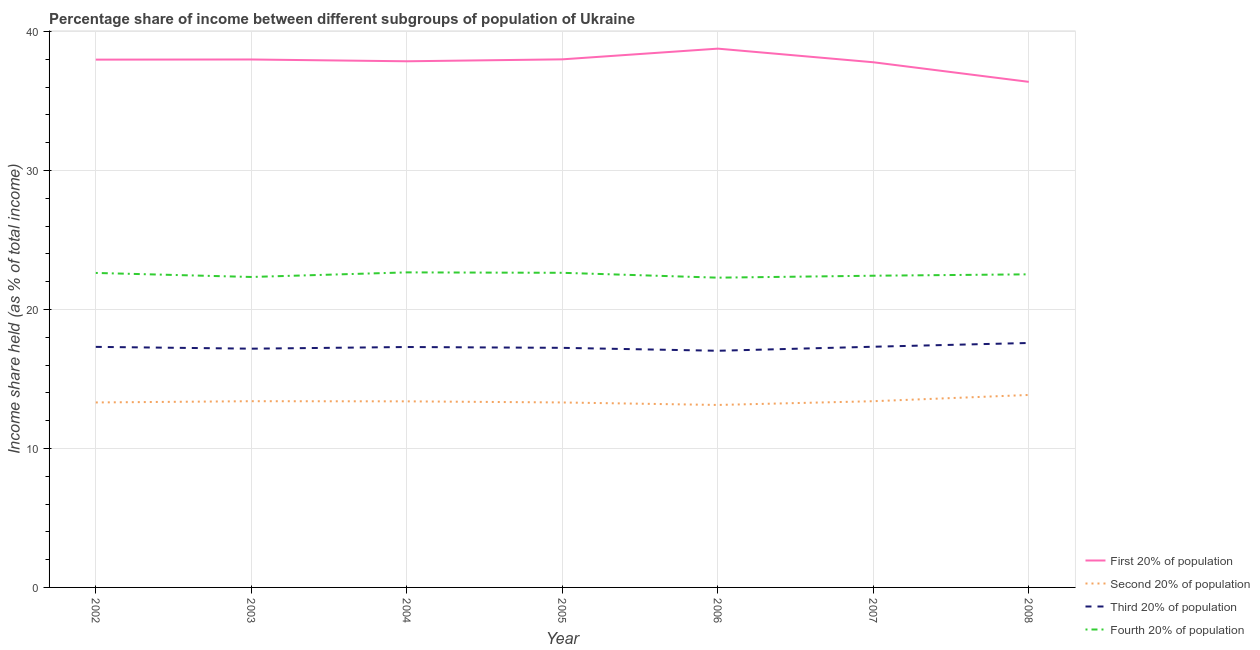How many different coloured lines are there?
Offer a terse response. 4. Is the number of lines equal to the number of legend labels?
Your answer should be compact. Yes. Across all years, what is the maximum share of the income held by first 20% of the population?
Offer a very short reply. 38.77. Across all years, what is the minimum share of the income held by first 20% of the population?
Keep it short and to the point. 36.38. In which year was the share of the income held by first 20% of the population maximum?
Provide a short and direct response. 2006. What is the total share of the income held by first 20% of the population in the graph?
Offer a terse response. 264.77. What is the difference between the share of the income held by first 20% of the population in 2005 and that in 2007?
Your response must be concise. 0.21. What is the difference between the share of the income held by third 20% of the population in 2007 and the share of the income held by fourth 20% of the population in 2008?
Offer a very short reply. -5.21. What is the average share of the income held by second 20% of the population per year?
Offer a terse response. 13.4. In the year 2007, what is the difference between the share of the income held by third 20% of the population and share of the income held by first 20% of the population?
Provide a short and direct response. -20.47. What is the ratio of the share of the income held by fourth 20% of the population in 2004 to that in 2008?
Make the answer very short. 1.01. Is the difference between the share of the income held by third 20% of the population in 2003 and 2004 greater than the difference between the share of the income held by fourth 20% of the population in 2003 and 2004?
Make the answer very short. Yes. What is the difference between the highest and the second highest share of the income held by third 20% of the population?
Offer a terse response. 0.27. What is the difference between the highest and the lowest share of the income held by first 20% of the population?
Your answer should be very brief. 2.39. Is the sum of the share of the income held by fourth 20% of the population in 2003 and 2005 greater than the maximum share of the income held by first 20% of the population across all years?
Keep it short and to the point. Yes. Is the share of the income held by first 20% of the population strictly less than the share of the income held by third 20% of the population over the years?
Provide a succinct answer. No. What is the difference between two consecutive major ticks on the Y-axis?
Provide a short and direct response. 10. Are the values on the major ticks of Y-axis written in scientific E-notation?
Offer a very short reply. No. Does the graph contain any zero values?
Provide a succinct answer. No. Does the graph contain grids?
Your response must be concise. Yes. How are the legend labels stacked?
Keep it short and to the point. Vertical. What is the title of the graph?
Give a very brief answer. Percentage share of income between different subgroups of population of Ukraine. What is the label or title of the X-axis?
Provide a short and direct response. Year. What is the label or title of the Y-axis?
Keep it short and to the point. Income share held (as % of total income). What is the Income share held (as % of total income) in First 20% of population in 2002?
Make the answer very short. 37.98. What is the Income share held (as % of total income) in Second 20% of population in 2002?
Provide a short and direct response. 13.31. What is the Income share held (as % of total income) in Third 20% of population in 2002?
Offer a terse response. 17.31. What is the Income share held (as % of total income) in Fourth 20% of population in 2002?
Provide a short and direct response. 22.63. What is the Income share held (as % of total income) of First 20% of population in 2003?
Give a very brief answer. 37.99. What is the Income share held (as % of total income) in Third 20% of population in 2003?
Keep it short and to the point. 17.18. What is the Income share held (as % of total income) in Fourth 20% of population in 2003?
Offer a terse response. 22.34. What is the Income share held (as % of total income) of First 20% of population in 2004?
Your answer should be very brief. 37.86. What is the Income share held (as % of total income) of Second 20% of population in 2004?
Give a very brief answer. 13.39. What is the Income share held (as % of total income) in Fourth 20% of population in 2004?
Keep it short and to the point. 22.67. What is the Income share held (as % of total income) of Second 20% of population in 2005?
Offer a very short reply. 13.31. What is the Income share held (as % of total income) in Third 20% of population in 2005?
Give a very brief answer. 17.24. What is the Income share held (as % of total income) of Fourth 20% of population in 2005?
Your answer should be very brief. 22.64. What is the Income share held (as % of total income) in First 20% of population in 2006?
Provide a succinct answer. 38.77. What is the Income share held (as % of total income) in Second 20% of population in 2006?
Ensure brevity in your answer.  13.13. What is the Income share held (as % of total income) in Third 20% of population in 2006?
Your answer should be very brief. 17.03. What is the Income share held (as % of total income) in Fourth 20% of population in 2006?
Give a very brief answer. 22.29. What is the Income share held (as % of total income) in First 20% of population in 2007?
Make the answer very short. 37.79. What is the Income share held (as % of total income) of Second 20% of population in 2007?
Offer a terse response. 13.4. What is the Income share held (as % of total income) in Third 20% of population in 2007?
Give a very brief answer. 17.32. What is the Income share held (as % of total income) in Fourth 20% of population in 2007?
Keep it short and to the point. 22.43. What is the Income share held (as % of total income) of First 20% of population in 2008?
Provide a short and direct response. 36.38. What is the Income share held (as % of total income) of Second 20% of population in 2008?
Your answer should be compact. 13.85. What is the Income share held (as % of total income) in Third 20% of population in 2008?
Give a very brief answer. 17.59. What is the Income share held (as % of total income) in Fourth 20% of population in 2008?
Ensure brevity in your answer.  22.53. Across all years, what is the maximum Income share held (as % of total income) of First 20% of population?
Keep it short and to the point. 38.77. Across all years, what is the maximum Income share held (as % of total income) in Second 20% of population?
Offer a terse response. 13.85. Across all years, what is the maximum Income share held (as % of total income) in Third 20% of population?
Your response must be concise. 17.59. Across all years, what is the maximum Income share held (as % of total income) in Fourth 20% of population?
Your answer should be compact. 22.67. Across all years, what is the minimum Income share held (as % of total income) of First 20% of population?
Keep it short and to the point. 36.38. Across all years, what is the minimum Income share held (as % of total income) in Second 20% of population?
Your answer should be compact. 13.13. Across all years, what is the minimum Income share held (as % of total income) in Third 20% of population?
Provide a short and direct response. 17.03. Across all years, what is the minimum Income share held (as % of total income) of Fourth 20% of population?
Keep it short and to the point. 22.29. What is the total Income share held (as % of total income) in First 20% of population in the graph?
Provide a succinct answer. 264.77. What is the total Income share held (as % of total income) in Second 20% of population in the graph?
Your answer should be very brief. 93.79. What is the total Income share held (as % of total income) in Third 20% of population in the graph?
Give a very brief answer. 120.97. What is the total Income share held (as % of total income) of Fourth 20% of population in the graph?
Your answer should be compact. 157.53. What is the difference between the Income share held (as % of total income) in First 20% of population in 2002 and that in 2003?
Provide a succinct answer. -0.01. What is the difference between the Income share held (as % of total income) of Second 20% of population in 2002 and that in 2003?
Offer a very short reply. -0.09. What is the difference between the Income share held (as % of total income) of Third 20% of population in 2002 and that in 2003?
Offer a very short reply. 0.13. What is the difference between the Income share held (as % of total income) in Fourth 20% of population in 2002 and that in 2003?
Offer a terse response. 0.29. What is the difference between the Income share held (as % of total income) of First 20% of population in 2002 and that in 2004?
Your answer should be very brief. 0.12. What is the difference between the Income share held (as % of total income) in Second 20% of population in 2002 and that in 2004?
Your answer should be very brief. -0.08. What is the difference between the Income share held (as % of total income) of Third 20% of population in 2002 and that in 2004?
Your answer should be very brief. 0.01. What is the difference between the Income share held (as % of total income) in Fourth 20% of population in 2002 and that in 2004?
Provide a short and direct response. -0.04. What is the difference between the Income share held (as % of total income) in First 20% of population in 2002 and that in 2005?
Offer a very short reply. -0.02. What is the difference between the Income share held (as % of total income) in Third 20% of population in 2002 and that in 2005?
Provide a succinct answer. 0.07. What is the difference between the Income share held (as % of total income) in Fourth 20% of population in 2002 and that in 2005?
Offer a very short reply. -0.01. What is the difference between the Income share held (as % of total income) in First 20% of population in 2002 and that in 2006?
Provide a succinct answer. -0.79. What is the difference between the Income share held (as % of total income) in Second 20% of population in 2002 and that in 2006?
Keep it short and to the point. 0.18. What is the difference between the Income share held (as % of total income) of Third 20% of population in 2002 and that in 2006?
Offer a very short reply. 0.28. What is the difference between the Income share held (as % of total income) in Fourth 20% of population in 2002 and that in 2006?
Your answer should be compact. 0.34. What is the difference between the Income share held (as % of total income) of First 20% of population in 2002 and that in 2007?
Keep it short and to the point. 0.19. What is the difference between the Income share held (as % of total income) of Second 20% of population in 2002 and that in 2007?
Provide a succinct answer. -0.09. What is the difference between the Income share held (as % of total income) of Third 20% of population in 2002 and that in 2007?
Make the answer very short. -0.01. What is the difference between the Income share held (as % of total income) of Fourth 20% of population in 2002 and that in 2007?
Offer a very short reply. 0.2. What is the difference between the Income share held (as % of total income) of First 20% of population in 2002 and that in 2008?
Give a very brief answer. 1.6. What is the difference between the Income share held (as % of total income) in Second 20% of population in 2002 and that in 2008?
Provide a succinct answer. -0.54. What is the difference between the Income share held (as % of total income) in Third 20% of population in 2002 and that in 2008?
Give a very brief answer. -0.28. What is the difference between the Income share held (as % of total income) in Fourth 20% of population in 2002 and that in 2008?
Make the answer very short. 0.1. What is the difference between the Income share held (as % of total income) of First 20% of population in 2003 and that in 2004?
Make the answer very short. 0.13. What is the difference between the Income share held (as % of total income) in Third 20% of population in 2003 and that in 2004?
Provide a succinct answer. -0.12. What is the difference between the Income share held (as % of total income) of Fourth 20% of population in 2003 and that in 2004?
Keep it short and to the point. -0.33. What is the difference between the Income share held (as % of total income) of First 20% of population in 2003 and that in 2005?
Your response must be concise. -0.01. What is the difference between the Income share held (as % of total income) of Second 20% of population in 2003 and that in 2005?
Make the answer very short. 0.09. What is the difference between the Income share held (as % of total income) in Third 20% of population in 2003 and that in 2005?
Offer a terse response. -0.06. What is the difference between the Income share held (as % of total income) in Fourth 20% of population in 2003 and that in 2005?
Your answer should be very brief. -0.3. What is the difference between the Income share held (as % of total income) of First 20% of population in 2003 and that in 2006?
Your response must be concise. -0.78. What is the difference between the Income share held (as % of total income) of Second 20% of population in 2003 and that in 2006?
Ensure brevity in your answer.  0.27. What is the difference between the Income share held (as % of total income) in Third 20% of population in 2003 and that in 2006?
Provide a succinct answer. 0.15. What is the difference between the Income share held (as % of total income) of Third 20% of population in 2003 and that in 2007?
Your response must be concise. -0.14. What is the difference between the Income share held (as % of total income) in Fourth 20% of population in 2003 and that in 2007?
Offer a terse response. -0.09. What is the difference between the Income share held (as % of total income) of First 20% of population in 2003 and that in 2008?
Make the answer very short. 1.61. What is the difference between the Income share held (as % of total income) of Second 20% of population in 2003 and that in 2008?
Provide a succinct answer. -0.45. What is the difference between the Income share held (as % of total income) in Third 20% of population in 2003 and that in 2008?
Provide a succinct answer. -0.41. What is the difference between the Income share held (as % of total income) in Fourth 20% of population in 2003 and that in 2008?
Your response must be concise. -0.19. What is the difference between the Income share held (as % of total income) of First 20% of population in 2004 and that in 2005?
Offer a very short reply. -0.14. What is the difference between the Income share held (as % of total income) of Fourth 20% of population in 2004 and that in 2005?
Offer a terse response. 0.03. What is the difference between the Income share held (as % of total income) in First 20% of population in 2004 and that in 2006?
Make the answer very short. -0.91. What is the difference between the Income share held (as % of total income) in Second 20% of population in 2004 and that in 2006?
Provide a succinct answer. 0.26. What is the difference between the Income share held (as % of total income) in Third 20% of population in 2004 and that in 2006?
Make the answer very short. 0.27. What is the difference between the Income share held (as % of total income) in Fourth 20% of population in 2004 and that in 2006?
Offer a very short reply. 0.38. What is the difference between the Income share held (as % of total income) of First 20% of population in 2004 and that in 2007?
Offer a very short reply. 0.07. What is the difference between the Income share held (as % of total income) in Second 20% of population in 2004 and that in 2007?
Your answer should be compact. -0.01. What is the difference between the Income share held (as % of total income) in Third 20% of population in 2004 and that in 2007?
Your response must be concise. -0.02. What is the difference between the Income share held (as % of total income) of Fourth 20% of population in 2004 and that in 2007?
Offer a terse response. 0.24. What is the difference between the Income share held (as % of total income) of First 20% of population in 2004 and that in 2008?
Offer a terse response. 1.48. What is the difference between the Income share held (as % of total income) in Second 20% of population in 2004 and that in 2008?
Keep it short and to the point. -0.46. What is the difference between the Income share held (as % of total income) in Third 20% of population in 2004 and that in 2008?
Offer a very short reply. -0.29. What is the difference between the Income share held (as % of total income) in Fourth 20% of population in 2004 and that in 2008?
Offer a terse response. 0.14. What is the difference between the Income share held (as % of total income) of First 20% of population in 2005 and that in 2006?
Your answer should be very brief. -0.77. What is the difference between the Income share held (as % of total income) in Second 20% of population in 2005 and that in 2006?
Your answer should be compact. 0.18. What is the difference between the Income share held (as % of total income) of Third 20% of population in 2005 and that in 2006?
Give a very brief answer. 0.21. What is the difference between the Income share held (as % of total income) in First 20% of population in 2005 and that in 2007?
Your answer should be compact. 0.21. What is the difference between the Income share held (as % of total income) of Second 20% of population in 2005 and that in 2007?
Your answer should be compact. -0.09. What is the difference between the Income share held (as % of total income) of Third 20% of population in 2005 and that in 2007?
Ensure brevity in your answer.  -0.08. What is the difference between the Income share held (as % of total income) in Fourth 20% of population in 2005 and that in 2007?
Keep it short and to the point. 0.21. What is the difference between the Income share held (as % of total income) of First 20% of population in 2005 and that in 2008?
Make the answer very short. 1.62. What is the difference between the Income share held (as % of total income) in Second 20% of population in 2005 and that in 2008?
Make the answer very short. -0.54. What is the difference between the Income share held (as % of total income) in Third 20% of population in 2005 and that in 2008?
Provide a short and direct response. -0.35. What is the difference between the Income share held (as % of total income) in Fourth 20% of population in 2005 and that in 2008?
Give a very brief answer. 0.11. What is the difference between the Income share held (as % of total income) of First 20% of population in 2006 and that in 2007?
Keep it short and to the point. 0.98. What is the difference between the Income share held (as % of total income) in Second 20% of population in 2006 and that in 2007?
Your answer should be very brief. -0.27. What is the difference between the Income share held (as % of total income) of Third 20% of population in 2006 and that in 2007?
Give a very brief answer. -0.29. What is the difference between the Income share held (as % of total income) of Fourth 20% of population in 2006 and that in 2007?
Make the answer very short. -0.14. What is the difference between the Income share held (as % of total income) of First 20% of population in 2006 and that in 2008?
Provide a succinct answer. 2.39. What is the difference between the Income share held (as % of total income) in Second 20% of population in 2006 and that in 2008?
Make the answer very short. -0.72. What is the difference between the Income share held (as % of total income) in Third 20% of population in 2006 and that in 2008?
Offer a terse response. -0.56. What is the difference between the Income share held (as % of total income) in Fourth 20% of population in 2006 and that in 2008?
Your response must be concise. -0.24. What is the difference between the Income share held (as % of total income) of First 20% of population in 2007 and that in 2008?
Ensure brevity in your answer.  1.41. What is the difference between the Income share held (as % of total income) in Second 20% of population in 2007 and that in 2008?
Offer a terse response. -0.45. What is the difference between the Income share held (as % of total income) in Third 20% of population in 2007 and that in 2008?
Offer a terse response. -0.27. What is the difference between the Income share held (as % of total income) in Fourth 20% of population in 2007 and that in 2008?
Offer a terse response. -0.1. What is the difference between the Income share held (as % of total income) of First 20% of population in 2002 and the Income share held (as % of total income) of Second 20% of population in 2003?
Ensure brevity in your answer.  24.58. What is the difference between the Income share held (as % of total income) in First 20% of population in 2002 and the Income share held (as % of total income) in Third 20% of population in 2003?
Make the answer very short. 20.8. What is the difference between the Income share held (as % of total income) of First 20% of population in 2002 and the Income share held (as % of total income) of Fourth 20% of population in 2003?
Your answer should be very brief. 15.64. What is the difference between the Income share held (as % of total income) of Second 20% of population in 2002 and the Income share held (as % of total income) of Third 20% of population in 2003?
Your response must be concise. -3.87. What is the difference between the Income share held (as % of total income) in Second 20% of population in 2002 and the Income share held (as % of total income) in Fourth 20% of population in 2003?
Offer a terse response. -9.03. What is the difference between the Income share held (as % of total income) of Third 20% of population in 2002 and the Income share held (as % of total income) of Fourth 20% of population in 2003?
Give a very brief answer. -5.03. What is the difference between the Income share held (as % of total income) of First 20% of population in 2002 and the Income share held (as % of total income) of Second 20% of population in 2004?
Provide a short and direct response. 24.59. What is the difference between the Income share held (as % of total income) of First 20% of population in 2002 and the Income share held (as % of total income) of Third 20% of population in 2004?
Make the answer very short. 20.68. What is the difference between the Income share held (as % of total income) in First 20% of population in 2002 and the Income share held (as % of total income) in Fourth 20% of population in 2004?
Provide a short and direct response. 15.31. What is the difference between the Income share held (as % of total income) of Second 20% of population in 2002 and the Income share held (as % of total income) of Third 20% of population in 2004?
Provide a succinct answer. -3.99. What is the difference between the Income share held (as % of total income) in Second 20% of population in 2002 and the Income share held (as % of total income) in Fourth 20% of population in 2004?
Your answer should be compact. -9.36. What is the difference between the Income share held (as % of total income) of Third 20% of population in 2002 and the Income share held (as % of total income) of Fourth 20% of population in 2004?
Offer a terse response. -5.36. What is the difference between the Income share held (as % of total income) in First 20% of population in 2002 and the Income share held (as % of total income) in Second 20% of population in 2005?
Offer a terse response. 24.67. What is the difference between the Income share held (as % of total income) in First 20% of population in 2002 and the Income share held (as % of total income) in Third 20% of population in 2005?
Your response must be concise. 20.74. What is the difference between the Income share held (as % of total income) of First 20% of population in 2002 and the Income share held (as % of total income) of Fourth 20% of population in 2005?
Provide a succinct answer. 15.34. What is the difference between the Income share held (as % of total income) in Second 20% of population in 2002 and the Income share held (as % of total income) in Third 20% of population in 2005?
Your answer should be very brief. -3.93. What is the difference between the Income share held (as % of total income) in Second 20% of population in 2002 and the Income share held (as % of total income) in Fourth 20% of population in 2005?
Provide a short and direct response. -9.33. What is the difference between the Income share held (as % of total income) of Third 20% of population in 2002 and the Income share held (as % of total income) of Fourth 20% of population in 2005?
Ensure brevity in your answer.  -5.33. What is the difference between the Income share held (as % of total income) of First 20% of population in 2002 and the Income share held (as % of total income) of Second 20% of population in 2006?
Make the answer very short. 24.85. What is the difference between the Income share held (as % of total income) of First 20% of population in 2002 and the Income share held (as % of total income) of Third 20% of population in 2006?
Your answer should be very brief. 20.95. What is the difference between the Income share held (as % of total income) of First 20% of population in 2002 and the Income share held (as % of total income) of Fourth 20% of population in 2006?
Your answer should be very brief. 15.69. What is the difference between the Income share held (as % of total income) of Second 20% of population in 2002 and the Income share held (as % of total income) of Third 20% of population in 2006?
Give a very brief answer. -3.72. What is the difference between the Income share held (as % of total income) of Second 20% of population in 2002 and the Income share held (as % of total income) of Fourth 20% of population in 2006?
Your answer should be compact. -8.98. What is the difference between the Income share held (as % of total income) of Third 20% of population in 2002 and the Income share held (as % of total income) of Fourth 20% of population in 2006?
Ensure brevity in your answer.  -4.98. What is the difference between the Income share held (as % of total income) in First 20% of population in 2002 and the Income share held (as % of total income) in Second 20% of population in 2007?
Provide a short and direct response. 24.58. What is the difference between the Income share held (as % of total income) in First 20% of population in 2002 and the Income share held (as % of total income) in Third 20% of population in 2007?
Provide a short and direct response. 20.66. What is the difference between the Income share held (as % of total income) in First 20% of population in 2002 and the Income share held (as % of total income) in Fourth 20% of population in 2007?
Your answer should be very brief. 15.55. What is the difference between the Income share held (as % of total income) in Second 20% of population in 2002 and the Income share held (as % of total income) in Third 20% of population in 2007?
Provide a succinct answer. -4.01. What is the difference between the Income share held (as % of total income) in Second 20% of population in 2002 and the Income share held (as % of total income) in Fourth 20% of population in 2007?
Provide a succinct answer. -9.12. What is the difference between the Income share held (as % of total income) of Third 20% of population in 2002 and the Income share held (as % of total income) of Fourth 20% of population in 2007?
Provide a succinct answer. -5.12. What is the difference between the Income share held (as % of total income) of First 20% of population in 2002 and the Income share held (as % of total income) of Second 20% of population in 2008?
Offer a very short reply. 24.13. What is the difference between the Income share held (as % of total income) of First 20% of population in 2002 and the Income share held (as % of total income) of Third 20% of population in 2008?
Your answer should be compact. 20.39. What is the difference between the Income share held (as % of total income) of First 20% of population in 2002 and the Income share held (as % of total income) of Fourth 20% of population in 2008?
Your answer should be very brief. 15.45. What is the difference between the Income share held (as % of total income) in Second 20% of population in 2002 and the Income share held (as % of total income) in Third 20% of population in 2008?
Provide a short and direct response. -4.28. What is the difference between the Income share held (as % of total income) of Second 20% of population in 2002 and the Income share held (as % of total income) of Fourth 20% of population in 2008?
Provide a short and direct response. -9.22. What is the difference between the Income share held (as % of total income) of Third 20% of population in 2002 and the Income share held (as % of total income) of Fourth 20% of population in 2008?
Keep it short and to the point. -5.22. What is the difference between the Income share held (as % of total income) of First 20% of population in 2003 and the Income share held (as % of total income) of Second 20% of population in 2004?
Offer a very short reply. 24.6. What is the difference between the Income share held (as % of total income) in First 20% of population in 2003 and the Income share held (as % of total income) in Third 20% of population in 2004?
Offer a very short reply. 20.69. What is the difference between the Income share held (as % of total income) of First 20% of population in 2003 and the Income share held (as % of total income) of Fourth 20% of population in 2004?
Provide a succinct answer. 15.32. What is the difference between the Income share held (as % of total income) in Second 20% of population in 2003 and the Income share held (as % of total income) in Third 20% of population in 2004?
Your response must be concise. -3.9. What is the difference between the Income share held (as % of total income) of Second 20% of population in 2003 and the Income share held (as % of total income) of Fourth 20% of population in 2004?
Give a very brief answer. -9.27. What is the difference between the Income share held (as % of total income) of Third 20% of population in 2003 and the Income share held (as % of total income) of Fourth 20% of population in 2004?
Make the answer very short. -5.49. What is the difference between the Income share held (as % of total income) in First 20% of population in 2003 and the Income share held (as % of total income) in Second 20% of population in 2005?
Provide a succinct answer. 24.68. What is the difference between the Income share held (as % of total income) in First 20% of population in 2003 and the Income share held (as % of total income) in Third 20% of population in 2005?
Keep it short and to the point. 20.75. What is the difference between the Income share held (as % of total income) in First 20% of population in 2003 and the Income share held (as % of total income) in Fourth 20% of population in 2005?
Provide a succinct answer. 15.35. What is the difference between the Income share held (as % of total income) in Second 20% of population in 2003 and the Income share held (as % of total income) in Third 20% of population in 2005?
Your answer should be compact. -3.84. What is the difference between the Income share held (as % of total income) of Second 20% of population in 2003 and the Income share held (as % of total income) of Fourth 20% of population in 2005?
Your response must be concise. -9.24. What is the difference between the Income share held (as % of total income) of Third 20% of population in 2003 and the Income share held (as % of total income) of Fourth 20% of population in 2005?
Offer a terse response. -5.46. What is the difference between the Income share held (as % of total income) in First 20% of population in 2003 and the Income share held (as % of total income) in Second 20% of population in 2006?
Offer a terse response. 24.86. What is the difference between the Income share held (as % of total income) in First 20% of population in 2003 and the Income share held (as % of total income) in Third 20% of population in 2006?
Make the answer very short. 20.96. What is the difference between the Income share held (as % of total income) of First 20% of population in 2003 and the Income share held (as % of total income) of Fourth 20% of population in 2006?
Your answer should be compact. 15.7. What is the difference between the Income share held (as % of total income) in Second 20% of population in 2003 and the Income share held (as % of total income) in Third 20% of population in 2006?
Offer a terse response. -3.63. What is the difference between the Income share held (as % of total income) in Second 20% of population in 2003 and the Income share held (as % of total income) in Fourth 20% of population in 2006?
Provide a succinct answer. -8.89. What is the difference between the Income share held (as % of total income) of Third 20% of population in 2003 and the Income share held (as % of total income) of Fourth 20% of population in 2006?
Your answer should be compact. -5.11. What is the difference between the Income share held (as % of total income) of First 20% of population in 2003 and the Income share held (as % of total income) of Second 20% of population in 2007?
Provide a succinct answer. 24.59. What is the difference between the Income share held (as % of total income) of First 20% of population in 2003 and the Income share held (as % of total income) of Third 20% of population in 2007?
Your response must be concise. 20.67. What is the difference between the Income share held (as % of total income) of First 20% of population in 2003 and the Income share held (as % of total income) of Fourth 20% of population in 2007?
Provide a succinct answer. 15.56. What is the difference between the Income share held (as % of total income) of Second 20% of population in 2003 and the Income share held (as % of total income) of Third 20% of population in 2007?
Keep it short and to the point. -3.92. What is the difference between the Income share held (as % of total income) of Second 20% of population in 2003 and the Income share held (as % of total income) of Fourth 20% of population in 2007?
Make the answer very short. -9.03. What is the difference between the Income share held (as % of total income) of Third 20% of population in 2003 and the Income share held (as % of total income) of Fourth 20% of population in 2007?
Your answer should be very brief. -5.25. What is the difference between the Income share held (as % of total income) of First 20% of population in 2003 and the Income share held (as % of total income) of Second 20% of population in 2008?
Your answer should be very brief. 24.14. What is the difference between the Income share held (as % of total income) of First 20% of population in 2003 and the Income share held (as % of total income) of Third 20% of population in 2008?
Your response must be concise. 20.4. What is the difference between the Income share held (as % of total income) in First 20% of population in 2003 and the Income share held (as % of total income) in Fourth 20% of population in 2008?
Make the answer very short. 15.46. What is the difference between the Income share held (as % of total income) of Second 20% of population in 2003 and the Income share held (as % of total income) of Third 20% of population in 2008?
Provide a short and direct response. -4.19. What is the difference between the Income share held (as % of total income) in Second 20% of population in 2003 and the Income share held (as % of total income) in Fourth 20% of population in 2008?
Provide a short and direct response. -9.13. What is the difference between the Income share held (as % of total income) in Third 20% of population in 2003 and the Income share held (as % of total income) in Fourth 20% of population in 2008?
Provide a short and direct response. -5.35. What is the difference between the Income share held (as % of total income) of First 20% of population in 2004 and the Income share held (as % of total income) of Second 20% of population in 2005?
Make the answer very short. 24.55. What is the difference between the Income share held (as % of total income) in First 20% of population in 2004 and the Income share held (as % of total income) in Third 20% of population in 2005?
Your response must be concise. 20.62. What is the difference between the Income share held (as % of total income) in First 20% of population in 2004 and the Income share held (as % of total income) in Fourth 20% of population in 2005?
Provide a short and direct response. 15.22. What is the difference between the Income share held (as % of total income) in Second 20% of population in 2004 and the Income share held (as % of total income) in Third 20% of population in 2005?
Ensure brevity in your answer.  -3.85. What is the difference between the Income share held (as % of total income) in Second 20% of population in 2004 and the Income share held (as % of total income) in Fourth 20% of population in 2005?
Provide a short and direct response. -9.25. What is the difference between the Income share held (as % of total income) in Third 20% of population in 2004 and the Income share held (as % of total income) in Fourth 20% of population in 2005?
Offer a terse response. -5.34. What is the difference between the Income share held (as % of total income) of First 20% of population in 2004 and the Income share held (as % of total income) of Second 20% of population in 2006?
Make the answer very short. 24.73. What is the difference between the Income share held (as % of total income) of First 20% of population in 2004 and the Income share held (as % of total income) of Third 20% of population in 2006?
Provide a short and direct response. 20.83. What is the difference between the Income share held (as % of total income) in First 20% of population in 2004 and the Income share held (as % of total income) in Fourth 20% of population in 2006?
Your answer should be compact. 15.57. What is the difference between the Income share held (as % of total income) of Second 20% of population in 2004 and the Income share held (as % of total income) of Third 20% of population in 2006?
Make the answer very short. -3.64. What is the difference between the Income share held (as % of total income) in Third 20% of population in 2004 and the Income share held (as % of total income) in Fourth 20% of population in 2006?
Make the answer very short. -4.99. What is the difference between the Income share held (as % of total income) in First 20% of population in 2004 and the Income share held (as % of total income) in Second 20% of population in 2007?
Give a very brief answer. 24.46. What is the difference between the Income share held (as % of total income) in First 20% of population in 2004 and the Income share held (as % of total income) in Third 20% of population in 2007?
Your response must be concise. 20.54. What is the difference between the Income share held (as % of total income) of First 20% of population in 2004 and the Income share held (as % of total income) of Fourth 20% of population in 2007?
Ensure brevity in your answer.  15.43. What is the difference between the Income share held (as % of total income) in Second 20% of population in 2004 and the Income share held (as % of total income) in Third 20% of population in 2007?
Offer a very short reply. -3.93. What is the difference between the Income share held (as % of total income) of Second 20% of population in 2004 and the Income share held (as % of total income) of Fourth 20% of population in 2007?
Your answer should be very brief. -9.04. What is the difference between the Income share held (as % of total income) of Third 20% of population in 2004 and the Income share held (as % of total income) of Fourth 20% of population in 2007?
Your answer should be very brief. -5.13. What is the difference between the Income share held (as % of total income) in First 20% of population in 2004 and the Income share held (as % of total income) in Second 20% of population in 2008?
Your response must be concise. 24.01. What is the difference between the Income share held (as % of total income) of First 20% of population in 2004 and the Income share held (as % of total income) of Third 20% of population in 2008?
Your answer should be very brief. 20.27. What is the difference between the Income share held (as % of total income) in First 20% of population in 2004 and the Income share held (as % of total income) in Fourth 20% of population in 2008?
Offer a very short reply. 15.33. What is the difference between the Income share held (as % of total income) of Second 20% of population in 2004 and the Income share held (as % of total income) of Third 20% of population in 2008?
Your answer should be very brief. -4.2. What is the difference between the Income share held (as % of total income) of Second 20% of population in 2004 and the Income share held (as % of total income) of Fourth 20% of population in 2008?
Ensure brevity in your answer.  -9.14. What is the difference between the Income share held (as % of total income) of Third 20% of population in 2004 and the Income share held (as % of total income) of Fourth 20% of population in 2008?
Your response must be concise. -5.23. What is the difference between the Income share held (as % of total income) in First 20% of population in 2005 and the Income share held (as % of total income) in Second 20% of population in 2006?
Keep it short and to the point. 24.87. What is the difference between the Income share held (as % of total income) of First 20% of population in 2005 and the Income share held (as % of total income) of Third 20% of population in 2006?
Offer a very short reply. 20.97. What is the difference between the Income share held (as % of total income) of First 20% of population in 2005 and the Income share held (as % of total income) of Fourth 20% of population in 2006?
Give a very brief answer. 15.71. What is the difference between the Income share held (as % of total income) of Second 20% of population in 2005 and the Income share held (as % of total income) of Third 20% of population in 2006?
Your answer should be very brief. -3.72. What is the difference between the Income share held (as % of total income) of Second 20% of population in 2005 and the Income share held (as % of total income) of Fourth 20% of population in 2006?
Your response must be concise. -8.98. What is the difference between the Income share held (as % of total income) of Third 20% of population in 2005 and the Income share held (as % of total income) of Fourth 20% of population in 2006?
Your answer should be compact. -5.05. What is the difference between the Income share held (as % of total income) of First 20% of population in 2005 and the Income share held (as % of total income) of Second 20% of population in 2007?
Provide a short and direct response. 24.6. What is the difference between the Income share held (as % of total income) in First 20% of population in 2005 and the Income share held (as % of total income) in Third 20% of population in 2007?
Ensure brevity in your answer.  20.68. What is the difference between the Income share held (as % of total income) of First 20% of population in 2005 and the Income share held (as % of total income) of Fourth 20% of population in 2007?
Give a very brief answer. 15.57. What is the difference between the Income share held (as % of total income) of Second 20% of population in 2005 and the Income share held (as % of total income) of Third 20% of population in 2007?
Your response must be concise. -4.01. What is the difference between the Income share held (as % of total income) in Second 20% of population in 2005 and the Income share held (as % of total income) in Fourth 20% of population in 2007?
Ensure brevity in your answer.  -9.12. What is the difference between the Income share held (as % of total income) in Third 20% of population in 2005 and the Income share held (as % of total income) in Fourth 20% of population in 2007?
Offer a very short reply. -5.19. What is the difference between the Income share held (as % of total income) of First 20% of population in 2005 and the Income share held (as % of total income) of Second 20% of population in 2008?
Give a very brief answer. 24.15. What is the difference between the Income share held (as % of total income) of First 20% of population in 2005 and the Income share held (as % of total income) of Third 20% of population in 2008?
Keep it short and to the point. 20.41. What is the difference between the Income share held (as % of total income) in First 20% of population in 2005 and the Income share held (as % of total income) in Fourth 20% of population in 2008?
Your response must be concise. 15.47. What is the difference between the Income share held (as % of total income) in Second 20% of population in 2005 and the Income share held (as % of total income) in Third 20% of population in 2008?
Ensure brevity in your answer.  -4.28. What is the difference between the Income share held (as % of total income) of Second 20% of population in 2005 and the Income share held (as % of total income) of Fourth 20% of population in 2008?
Your response must be concise. -9.22. What is the difference between the Income share held (as % of total income) in Third 20% of population in 2005 and the Income share held (as % of total income) in Fourth 20% of population in 2008?
Offer a very short reply. -5.29. What is the difference between the Income share held (as % of total income) of First 20% of population in 2006 and the Income share held (as % of total income) of Second 20% of population in 2007?
Your answer should be very brief. 25.37. What is the difference between the Income share held (as % of total income) of First 20% of population in 2006 and the Income share held (as % of total income) of Third 20% of population in 2007?
Offer a very short reply. 21.45. What is the difference between the Income share held (as % of total income) of First 20% of population in 2006 and the Income share held (as % of total income) of Fourth 20% of population in 2007?
Offer a terse response. 16.34. What is the difference between the Income share held (as % of total income) in Second 20% of population in 2006 and the Income share held (as % of total income) in Third 20% of population in 2007?
Keep it short and to the point. -4.19. What is the difference between the Income share held (as % of total income) of Third 20% of population in 2006 and the Income share held (as % of total income) of Fourth 20% of population in 2007?
Your answer should be compact. -5.4. What is the difference between the Income share held (as % of total income) in First 20% of population in 2006 and the Income share held (as % of total income) in Second 20% of population in 2008?
Your answer should be very brief. 24.92. What is the difference between the Income share held (as % of total income) in First 20% of population in 2006 and the Income share held (as % of total income) in Third 20% of population in 2008?
Provide a short and direct response. 21.18. What is the difference between the Income share held (as % of total income) in First 20% of population in 2006 and the Income share held (as % of total income) in Fourth 20% of population in 2008?
Make the answer very short. 16.24. What is the difference between the Income share held (as % of total income) of Second 20% of population in 2006 and the Income share held (as % of total income) of Third 20% of population in 2008?
Give a very brief answer. -4.46. What is the difference between the Income share held (as % of total income) of Second 20% of population in 2006 and the Income share held (as % of total income) of Fourth 20% of population in 2008?
Offer a terse response. -9.4. What is the difference between the Income share held (as % of total income) in First 20% of population in 2007 and the Income share held (as % of total income) in Second 20% of population in 2008?
Offer a terse response. 23.94. What is the difference between the Income share held (as % of total income) in First 20% of population in 2007 and the Income share held (as % of total income) in Third 20% of population in 2008?
Ensure brevity in your answer.  20.2. What is the difference between the Income share held (as % of total income) in First 20% of population in 2007 and the Income share held (as % of total income) in Fourth 20% of population in 2008?
Give a very brief answer. 15.26. What is the difference between the Income share held (as % of total income) of Second 20% of population in 2007 and the Income share held (as % of total income) of Third 20% of population in 2008?
Provide a short and direct response. -4.19. What is the difference between the Income share held (as % of total income) in Second 20% of population in 2007 and the Income share held (as % of total income) in Fourth 20% of population in 2008?
Offer a very short reply. -9.13. What is the difference between the Income share held (as % of total income) in Third 20% of population in 2007 and the Income share held (as % of total income) in Fourth 20% of population in 2008?
Keep it short and to the point. -5.21. What is the average Income share held (as % of total income) in First 20% of population per year?
Provide a succinct answer. 37.82. What is the average Income share held (as % of total income) of Second 20% of population per year?
Provide a succinct answer. 13.4. What is the average Income share held (as % of total income) of Third 20% of population per year?
Give a very brief answer. 17.28. What is the average Income share held (as % of total income) of Fourth 20% of population per year?
Give a very brief answer. 22.5. In the year 2002, what is the difference between the Income share held (as % of total income) in First 20% of population and Income share held (as % of total income) in Second 20% of population?
Provide a succinct answer. 24.67. In the year 2002, what is the difference between the Income share held (as % of total income) of First 20% of population and Income share held (as % of total income) of Third 20% of population?
Your answer should be compact. 20.67. In the year 2002, what is the difference between the Income share held (as % of total income) of First 20% of population and Income share held (as % of total income) of Fourth 20% of population?
Keep it short and to the point. 15.35. In the year 2002, what is the difference between the Income share held (as % of total income) of Second 20% of population and Income share held (as % of total income) of Third 20% of population?
Provide a succinct answer. -4. In the year 2002, what is the difference between the Income share held (as % of total income) in Second 20% of population and Income share held (as % of total income) in Fourth 20% of population?
Offer a very short reply. -9.32. In the year 2002, what is the difference between the Income share held (as % of total income) in Third 20% of population and Income share held (as % of total income) in Fourth 20% of population?
Offer a terse response. -5.32. In the year 2003, what is the difference between the Income share held (as % of total income) in First 20% of population and Income share held (as % of total income) in Second 20% of population?
Provide a short and direct response. 24.59. In the year 2003, what is the difference between the Income share held (as % of total income) of First 20% of population and Income share held (as % of total income) of Third 20% of population?
Provide a short and direct response. 20.81. In the year 2003, what is the difference between the Income share held (as % of total income) in First 20% of population and Income share held (as % of total income) in Fourth 20% of population?
Offer a very short reply. 15.65. In the year 2003, what is the difference between the Income share held (as % of total income) in Second 20% of population and Income share held (as % of total income) in Third 20% of population?
Provide a succinct answer. -3.78. In the year 2003, what is the difference between the Income share held (as % of total income) of Second 20% of population and Income share held (as % of total income) of Fourth 20% of population?
Your answer should be very brief. -8.94. In the year 2003, what is the difference between the Income share held (as % of total income) in Third 20% of population and Income share held (as % of total income) in Fourth 20% of population?
Your answer should be very brief. -5.16. In the year 2004, what is the difference between the Income share held (as % of total income) in First 20% of population and Income share held (as % of total income) in Second 20% of population?
Make the answer very short. 24.47. In the year 2004, what is the difference between the Income share held (as % of total income) of First 20% of population and Income share held (as % of total income) of Third 20% of population?
Offer a terse response. 20.56. In the year 2004, what is the difference between the Income share held (as % of total income) of First 20% of population and Income share held (as % of total income) of Fourth 20% of population?
Your answer should be very brief. 15.19. In the year 2004, what is the difference between the Income share held (as % of total income) in Second 20% of population and Income share held (as % of total income) in Third 20% of population?
Offer a terse response. -3.91. In the year 2004, what is the difference between the Income share held (as % of total income) in Second 20% of population and Income share held (as % of total income) in Fourth 20% of population?
Make the answer very short. -9.28. In the year 2004, what is the difference between the Income share held (as % of total income) in Third 20% of population and Income share held (as % of total income) in Fourth 20% of population?
Offer a very short reply. -5.37. In the year 2005, what is the difference between the Income share held (as % of total income) of First 20% of population and Income share held (as % of total income) of Second 20% of population?
Keep it short and to the point. 24.69. In the year 2005, what is the difference between the Income share held (as % of total income) of First 20% of population and Income share held (as % of total income) of Third 20% of population?
Keep it short and to the point. 20.76. In the year 2005, what is the difference between the Income share held (as % of total income) in First 20% of population and Income share held (as % of total income) in Fourth 20% of population?
Offer a very short reply. 15.36. In the year 2005, what is the difference between the Income share held (as % of total income) in Second 20% of population and Income share held (as % of total income) in Third 20% of population?
Give a very brief answer. -3.93. In the year 2005, what is the difference between the Income share held (as % of total income) of Second 20% of population and Income share held (as % of total income) of Fourth 20% of population?
Give a very brief answer. -9.33. In the year 2006, what is the difference between the Income share held (as % of total income) in First 20% of population and Income share held (as % of total income) in Second 20% of population?
Offer a terse response. 25.64. In the year 2006, what is the difference between the Income share held (as % of total income) in First 20% of population and Income share held (as % of total income) in Third 20% of population?
Your response must be concise. 21.74. In the year 2006, what is the difference between the Income share held (as % of total income) in First 20% of population and Income share held (as % of total income) in Fourth 20% of population?
Provide a succinct answer. 16.48. In the year 2006, what is the difference between the Income share held (as % of total income) in Second 20% of population and Income share held (as % of total income) in Fourth 20% of population?
Keep it short and to the point. -9.16. In the year 2006, what is the difference between the Income share held (as % of total income) in Third 20% of population and Income share held (as % of total income) in Fourth 20% of population?
Offer a terse response. -5.26. In the year 2007, what is the difference between the Income share held (as % of total income) of First 20% of population and Income share held (as % of total income) of Second 20% of population?
Provide a succinct answer. 24.39. In the year 2007, what is the difference between the Income share held (as % of total income) in First 20% of population and Income share held (as % of total income) in Third 20% of population?
Give a very brief answer. 20.47. In the year 2007, what is the difference between the Income share held (as % of total income) of First 20% of population and Income share held (as % of total income) of Fourth 20% of population?
Provide a short and direct response. 15.36. In the year 2007, what is the difference between the Income share held (as % of total income) of Second 20% of population and Income share held (as % of total income) of Third 20% of population?
Provide a short and direct response. -3.92. In the year 2007, what is the difference between the Income share held (as % of total income) in Second 20% of population and Income share held (as % of total income) in Fourth 20% of population?
Your response must be concise. -9.03. In the year 2007, what is the difference between the Income share held (as % of total income) in Third 20% of population and Income share held (as % of total income) in Fourth 20% of population?
Provide a short and direct response. -5.11. In the year 2008, what is the difference between the Income share held (as % of total income) in First 20% of population and Income share held (as % of total income) in Second 20% of population?
Your answer should be very brief. 22.53. In the year 2008, what is the difference between the Income share held (as % of total income) in First 20% of population and Income share held (as % of total income) in Third 20% of population?
Your response must be concise. 18.79. In the year 2008, what is the difference between the Income share held (as % of total income) in First 20% of population and Income share held (as % of total income) in Fourth 20% of population?
Your answer should be very brief. 13.85. In the year 2008, what is the difference between the Income share held (as % of total income) in Second 20% of population and Income share held (as % of total income) in Third 20% of population?
Make the answer very short. -3.74. In the year 2008, what is the difference between the Income share held (as % of total income) in Second 20% of population and Income share held (as % of total income) in Fourth 20% of population?
Offer a very short reply. -8.68. In the year 2008, what is the difference between the Income share held (as % of total income) in Third 20% of population and Income share held (as % of total income) in Fourth 20% of population?
Provide a succinct answer. -4.94. What is the ratio of the Income share held (as % of total income) in First 20% of population in 2002 to that in 2003?
Give a very brief answer. 1. What is the ratio of the Income share held (as % of total income) in Second 20% of population in 2002 to that in 2003?
Your answer should be very brief. 0.99. What is the ratio of the Income share held (as % of total income) in Third 20% of population in 2002 to that in 2003?
Offer a very short reply. 1.01. What is the ratio of the Income share held (as % of total income) of Fourth 20% of population in 2002 to that in 2003?
Make the answer very short. 1.01. What is the ratio of the Income share held (as % of total income) in Third 20% of population in 2002 to that in 2004?
Keep it short and to the point. 1. What is the ratio of the Income share held (as % of total income) in First 20% of population in 2002 to that in 2005?
Your answer should be very brief. 1. What is the ratio of the Income share held (as % of total income) in Fourth 20% of population in 2002 to that in 2005?
Give a very brief answer. 1. What is the ratio of the Income share held (as % of total income) of First 20% of population in 2002 to that in 2006?
Offer a terse response. 0.98. What is the ratio of the Income share held (as % of total income) of Second 20% of population in 2002 to that in 2006?
Ensure brevity in your answer.  1.01. What is the ratio of the Income share held (as % of total income) in Third 20% of population in 2002 to that in 2006?
Ensure brevity in your answer.  1.02. What is the ratio of the Income share held (as % of total income) of Fourth 20% of population in 2002 to that in 2006?
Provide a short and direct response. 1.02. What is the ratio of the Income share held (as % of total income) in Second 20% of population in 2002 to that in 2007?
Keep it short and to the point. 0.99. What is the ratio of the Income share held (as % of total income) of Fourth 20% of population in 2002 to that in 2007?
Make the answer very short. 1.01. What is the ratio of the Income share held (as % of total income) of First 20% of population in 2002 to that in 2008?
Make the answer very short. 1.04. What is the ratio of the Income share held (as % of total income) of Second 20% of population in 2002 to that in 2008?
Provide a short and direct response. 0.96. What is the ratio of the Income share held (as % of total income) of Third 20% of population in 2002 to that in 2008?
Give a very brief answer. 0.98. What is the ratio of the Income share held (as % of total income) in Third 20% of population in 2003 to that in 2004?
Ensure brevity in your answer.  0.99. What is the ratio of the Income share held (as % of total income) in Fourth 20% of population in 2003 to that in 2004?
Your answer should be compact. 0.99. What is the ratio of the Income share held (as % of total income) in First 20% of population in 2003 to that in 2005?
Offer a very short reply. 1. What is the ratio of the Income share held (as % of total income) of Second 20% of population in 2003 to that in 2005?
Offer a very short reply. 1.01. What is the ratio of the Income share held (as % of total income) of Fourth 20% of population in 2003 to that in 2005?
Offer a terse response. 0.99. What is the ratio of the Income share held (as % of total income) of First 20% of population in 2003 to that in 2006?
Make the answer very short. 0.98. What is the ratio of the Income share held (as % of total income) of Second 20% of population in 2003 to that in 2006?
Offer a very short reply. 1.02. What is the ratio of the Income share held (as % of total income) in Third 20% of population in 2003 to that in 2006?
Provide a succinct answer. 1.01. What is the ratio of the Income share held (as % of total income) of First 20% of population in 2003 to that in 2007?
Your response must be concise. 1.01. What is the ratio of the Income share held (as % of total income) of Third 20% of population in 2003 to that in 2007?
Your answer should be compact. 0.99. What is the ratio of the Income share held (as % of total income) in Fourth 20% of population in 2003 to that in 2007?
Ensure brevity in your answer.  1. What is the ratio of the Income share held (as % of total income) in First 20% of population in 2003 to that in 2008?
Your response must be concise. 1.04. What is the ratio of the Income share held (as % of total income) in Second 20% of population in 2003 to that in 2008?
Offer a terse response. 0.97. What is the ratio of the Income share held (as % of total income) in Third 20% of population in 2003 to that in 2008?
Make the answer very short. 0.98. What is the ratio of the Income share held (as % of total income) in First 20% of population in 2004 to that in 2005?
Offer a terse response. 1. What is the ratio of the Income share held (as % of total income) in Second 20% of population in 2004 to that in 2005?
Offer a very short reply. 1.01. What is the ratio of the Income share held (as % of total income) of Third 20% of population in 2004 to that in 2005?
Provide a succinct answer. 1. What is the ratio of the Income share held (as % of total income) in First 20% of population in 2004 to that in 2006?
Ensure brevity in your answer.  0.98. What is the ratio of the Income share held (as % of total income) in Second 20% of population in 2004 to that in 2006?
Offer a terse response. 1.02. What is the ratio of the Income share held (as % of total income) of Third 20% of population in 2004 to that in 2006?
Offer a very short reply. 1.02. What is the ratio of the Income share held (as % of total income) in Fourth 20% of population in 2004 to that in 2006?
Keep it short and to the point. 1.02. What is the ratio of the Income share held (as % of total income) in First 20% of population in 2004 to that in 2007?
Your response must be concise. 1. What is the ratio of the Income share held (as % of total income) in Third 20% of population in 2004 to that in 2007?
Provide a succinct answer. 1. What is the ratio of the Income share held (as % of total income) in Fourth 20% of population in 2004 to that in 2007?
Make the answer very short. 1.01. What is the ratio of the Income share held (as % of total income) in First 20% of population in 2004 to that in 2008?
Offer a terse response. 1.04. What is the ratio of the Income share held (as % of total income) in Second 20% of population in 2004 to that in 2008?
Your answer should be very brief. 0.97. What is the ratio of the Income share held (as % of total income) of Third 20% of population in 2004 to that in 2008?
Give a very brief answer. 0.98. What is the ratio of the Income share held (as % of total income) of Fourth 20% of population in 2004 to that in 2008?
Offer a terse response. 1.01. What is the ratio of the Income share held (as % of total income) in First 20% of population in 2005 to that in 2006?
Keep it short and to the point. 0.98. What is the ratio of the Income share held (as % of total income) in Second 20% of population in 2005 to that in 2006?
Your answer should be very brief. 1.01. What is the ratio of the Income share held (as % of total income) in Third 20% of population in 2005 to that in 2006?
Your answer should be very brief. 1.01. What is the ratio of the Income share held (as % of total income) of Fourth 20% of population in 2005 to that in 2006?
Provide a succinct answer. 1.02. What is the ratio of the Income share held (as % of total income) in First 20% of population in 2005 to that in 2007?
Your answer should be very brief. 1.01. What is the ratio of the Income share held (as % of total income) in Fourth 20% of population in 2005 to that in 2007?
Offer a very short reply. 1.01. What is the ratio of the Income share held (as % of total income) of First 20% of population in 2005 to that in 2008?
Your answer should be compact. 1.04. What is the ratio of the Income share held (as % of total income) in Second 20% of population in 2005 to that in 2008?
Keep it short and to the point. 0.96. What is the ratio of the Income share held (as % of total income) in Third 20% of population in 2005 to that in 2008?
Your response must be concise. 0.98. What is the ratio of the Income share held (as % of total income) in Fourth 20% of population in 2005 to that in 2008?
Give a very brief answer. 1. What is the ratio of the Income share held (as % of total income) of First 20% of population in 2006 to that in 2007?
Ensure brevity in your answer.  1.03. What is the ratio of the Income share held (as % of total income) of Second 20% of population in 2006 to that in 2007?
Your answer should be very brief. 0.98. What is the ratio of the Income share held (as % of total income) of Third 20% of population in 2006 to that in 2007?
Offer a very short reply. 0.98. What is the ratio of the Income share held (as % of total income) of First 20% of population in 2006 to that in 2008?
Provide a succinct answer. 1.07. What is the ratio of the Income share held (as % of total income) in Second 20% of population in 2006 to that in 2008?
Keep it short and to the point. 0.95. What is the ratio of the Income share held (as % of total income) in Third 20% of population in 2006 to that in 2008?
Give a very brief answer. 0.97. What is the ratio of the Income share held (as % of total income) of Fourth 20% of population in 2006 to that in 2008?
Your answer should be very brief. 0.99. What is the ratio of the Income share held (as % of total income) in First 20% of population in 2007 to that in 2008?
Your response must be concise. 1.04. What is the ratio of the Income share held (as % of total income) of Second 20% of population in 2007 to that in 2008?
Keep it short and to the point. 0.97. What is the ratio of the Income share held (as % of total income) of Third 20% of population in 2007 to that in 2008?
Make the answer very short. 0.98. What is the difference between the highest and the second highest Income share held (as % of total income) of First 20% of population?
Provide a short and direct response. 0.77. What is the difference between the highest and the second highest Income share held (as % of total income) in Second 20% of population?
Offer a terse response. 0.45. What is the difference between the highest and the second highest Income share held (as % of total income) in Third 20% of population?
Make the answer very short. 0.27. What is the difference between the highest and the lowest Income share held (as % of total income) in First 20% of population?
Provide a succinct answer. 2.39. What is the difference between the highest and the lowest Income share held (as % of total income) of Second 20% of population?
Your answer should be compact. 0.72. What is the difference between the highest and the lowest Income share held (as % of total income) in Third 20% of population?
Keep it short and to the point. 0.56. What is the difference between the highest and the lowest Income share held (as % of total income) in Fourth 20% of population?
Offer a terse response. 0.38. 